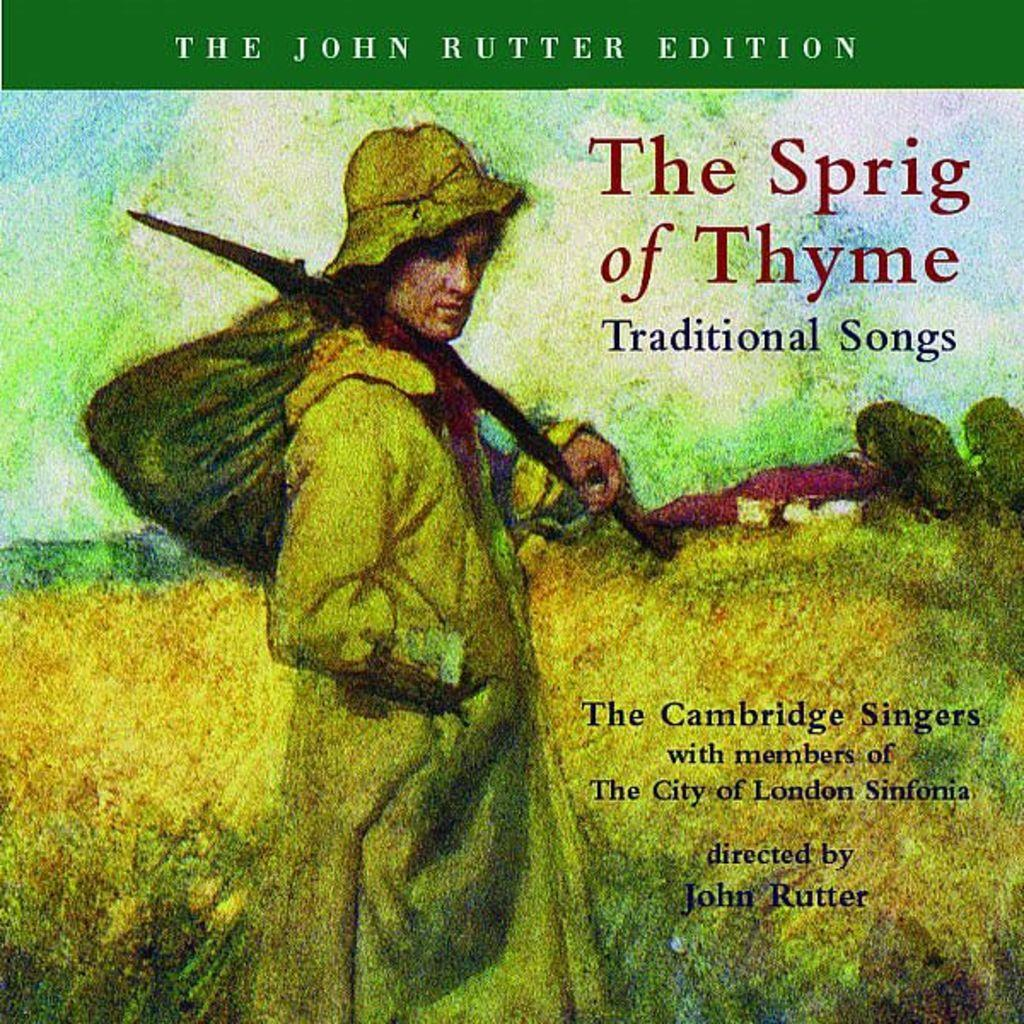What type of visual is the image? The image is a poster. What can be found on the poster besides the visual elements? There is text written on the poster. What is the person in the poster holding? The person is holding a bag with a stick in the poster. What is the person standing on in the poster? The person is standing on the surface of the grass in the poster. What type of board is the person riding in the poster? There is no board present in the poster; the person is standing on the grass. What advice does the person's father give in the poster? There is no father or advice given in the poster; it only shows a person holding a bag with a stick and standing on grass. 